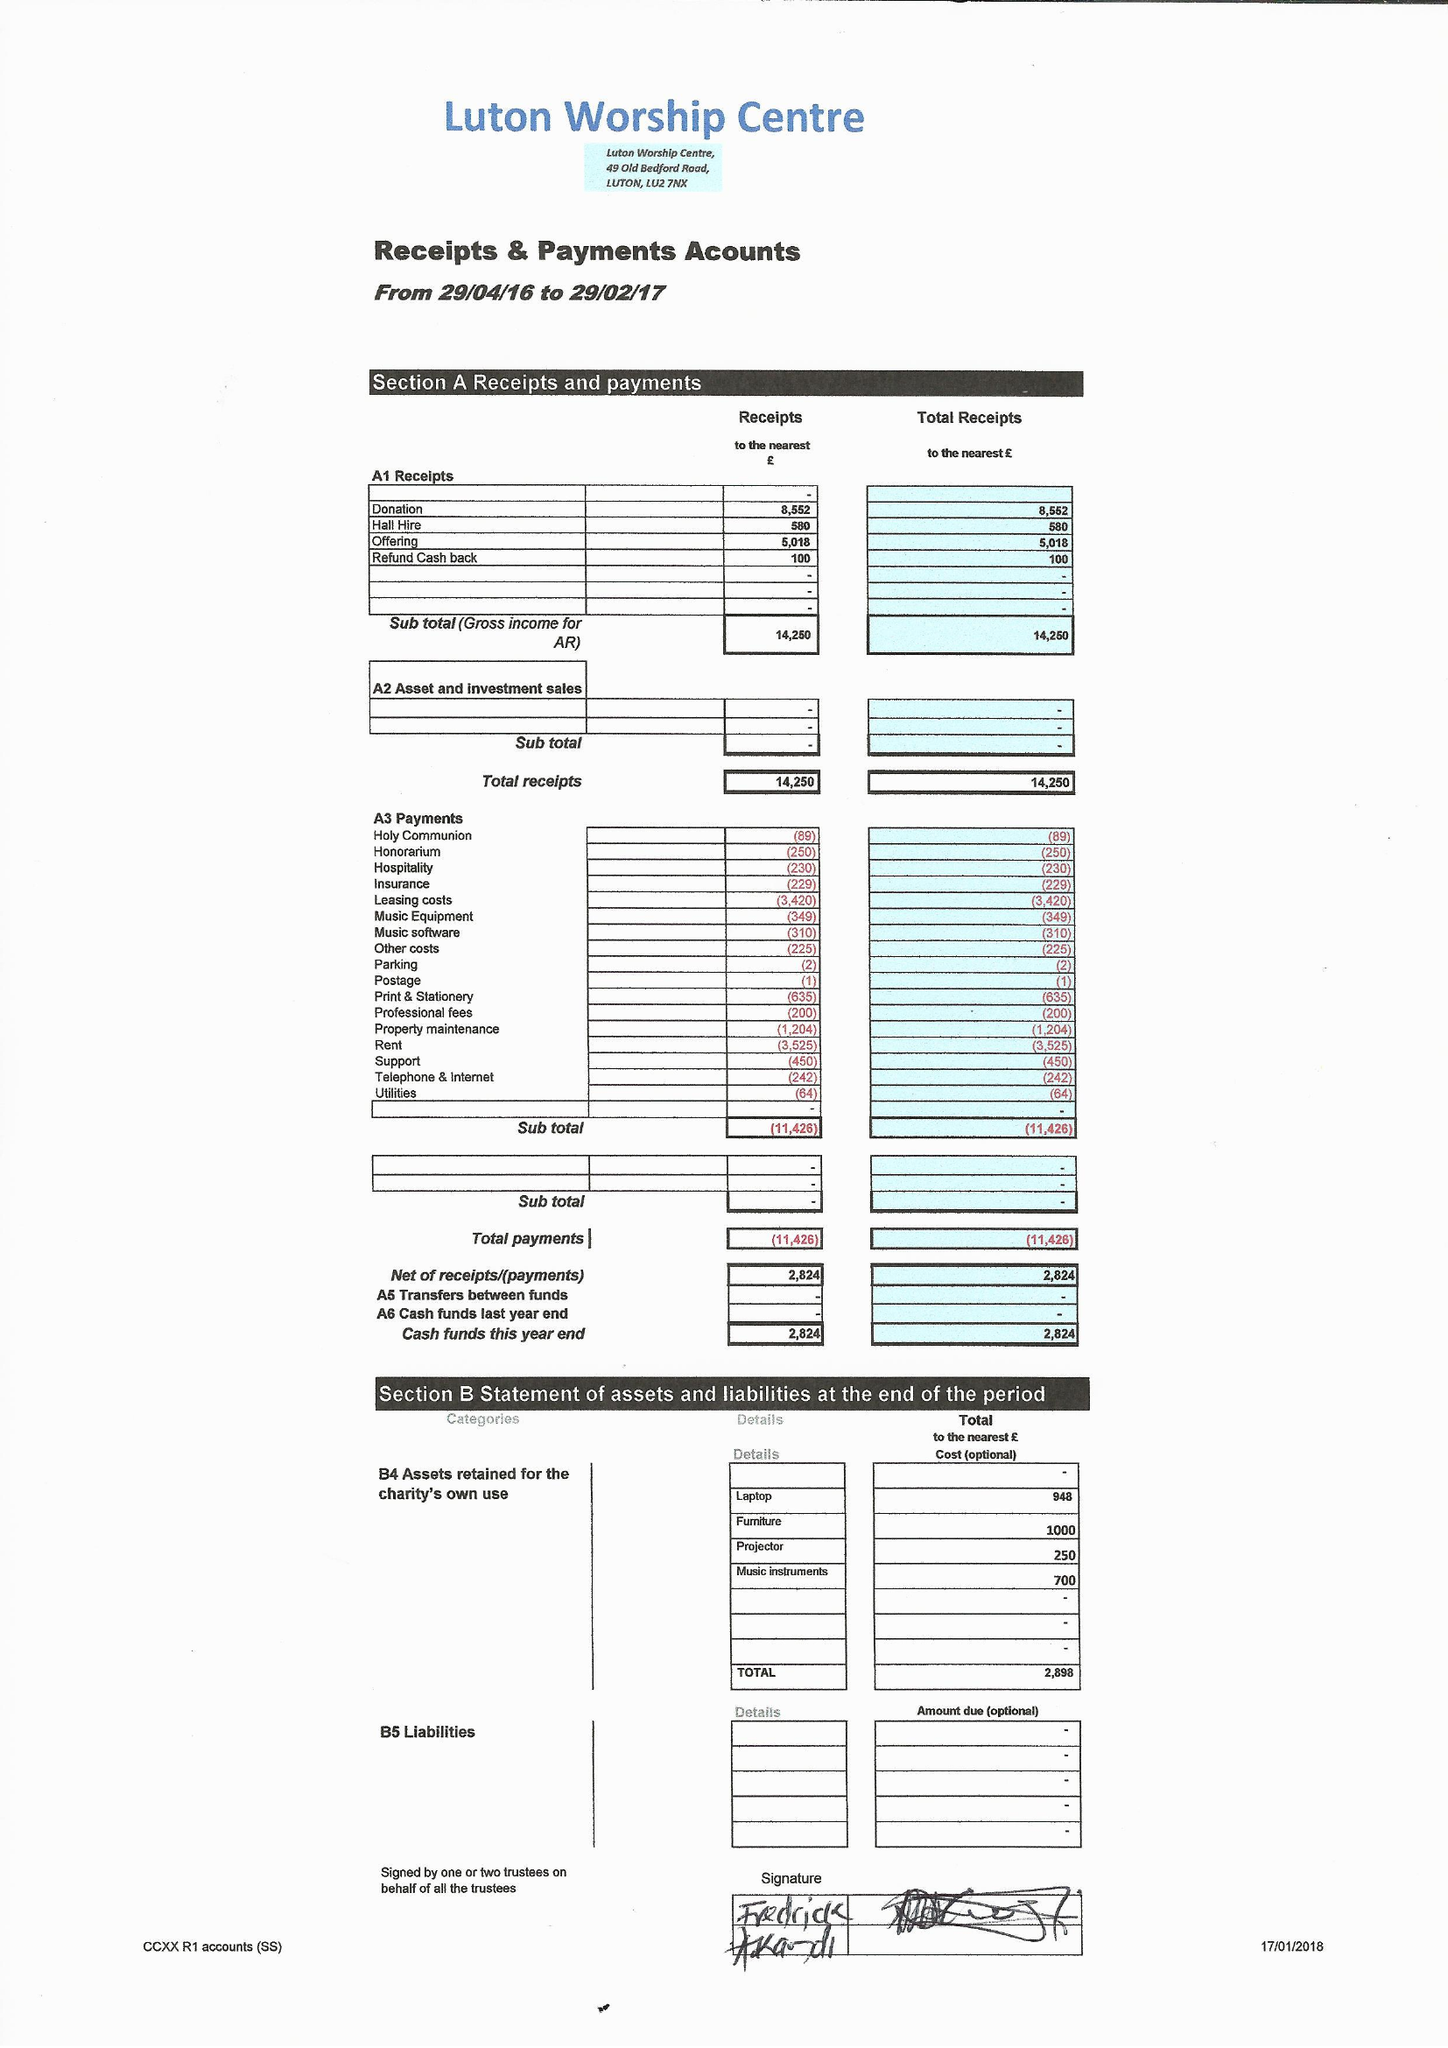What is the value for the charity_number?
Answer the question using a single word or phrase. 1166848 